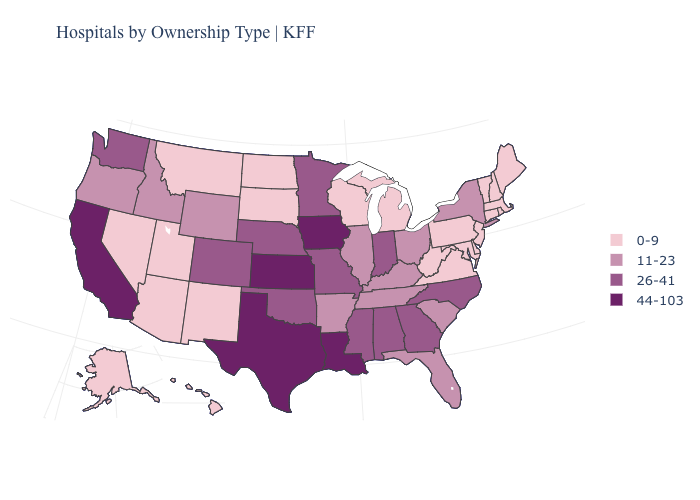Does Wisconsin have the lowest value in the MidWest?
Answer briefly. Yes. Name the states that have a value in the range 44-103?
Be succinct. California, Iowa, Kansas, Louisiana, Texas. Does Maryland have the lowest value in the USA?
Answer briefly. Yes. Does Alabama have a higher value than New Mexico?
Give a very brief answer. Yes. Name the states that have a value in the range 11-23?
Short answer required. Arkansas, Florida, Idaho, Illinois, Kentucky, New York, Ohio, Oregon, South Carolina, Tennessee, Wyoming. Does California have the highest value in the USA?
Answer briefly. Yes. Does the map have missing data?
Keep it brief. No. What is the highest value in the Northeast ?
Give a very brief answer. 11-23. Does the map have missing data?
Quick response, please. No. What is the value of Delaware?
Give a very brief answer. 0-9. Name the states that have a value in the range 26-41?
Answer briefly. Alabama, Colorado, Georgia, Indiana, Minnesota, Mississippi, Missouri, Nebraska, North Carolina, Oklahoma, Washington. What is the lowest value in the MidWest?
Be succinct. 0-9. Does Washington have the lowest value in the USA?
Keep it brief. No. Which states have the lowest value in the Northeast?
Quick response, please. Connecticut, Maine, Massachusetts, New Hampshire, New Jersey, Pennsylvania, Rhode Island, Vermont. Does Nevada have the lowest value in the West?
Write a very short answer. Yes. 